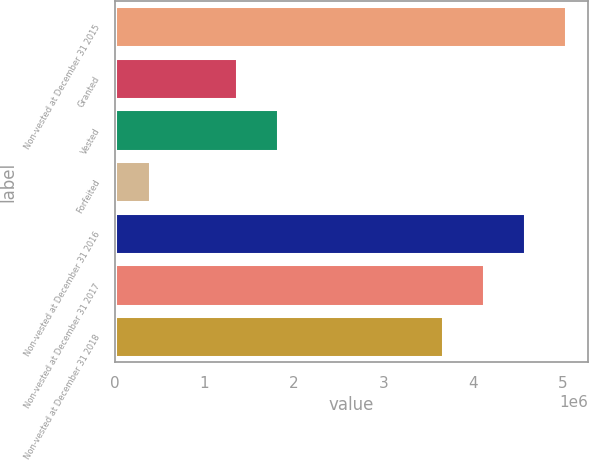<chart> <loc_0><loc_0><loc_500><loc_500><bar_chart><fcel>Non-vested at December 31 2015<fcel>Granted<fcel>Vested<fcel>Forfeited<fcel>Non-vested at December 31 2016<fcel>Non-vested at December 31 2017<fcel>Non-vested at December 31 2018<nl><fcel>5.03459e+06<fcel>1.36447e+06<fcel>1.82337e+06<fcel>392541<fcel>4.57568e+06<fcel>4.11678e+06<fcel>3.65787e+06<nl></chart> 